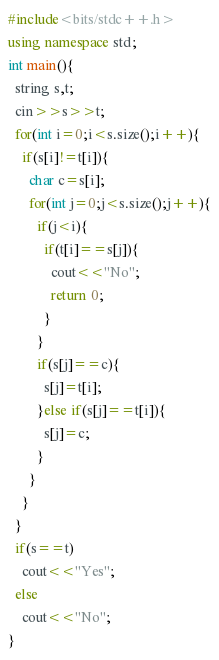<code> <loc_0><loc_0><loc_500><loc_500><_C++_>#include<bits/stdc++.h>
using namespace std;
int main(){
  string s,t;
  cin>>s>>t;
  for(int i=0;i<s.size();i++){
    if(s[i]!=t[i]){
      char c=s[i];
      for(int j=0;j<s.size();j++){
        if(j<i){
          if(t[i]==s[j]){
            cout<<"No";
            return 0;
          }
        }
        if(s[j]==c){
          s[j]=t[i];
        }else if(s[j]==t[i]){
          s[j]=c;
        }
      }
    }
  }
  if(s==t)
    cout<<"Yes";
  else
    cout<<"No";
}
</code> 